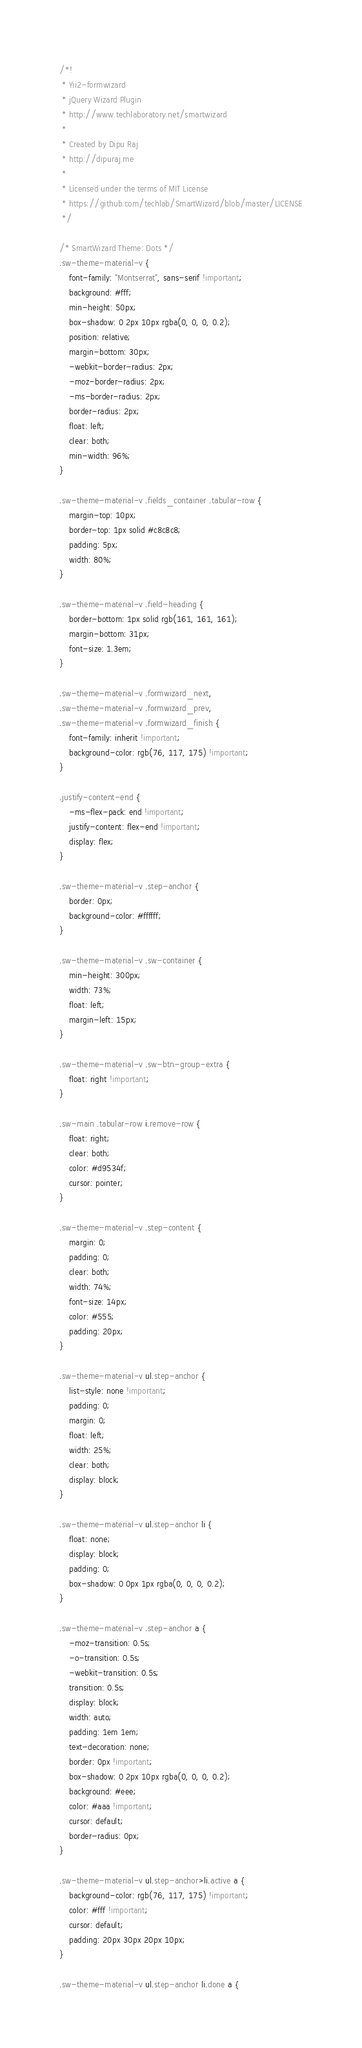Convert code to text. <code><loc_0><loc_0><loc_500><loc_500><_CSS_>/*!
 * Yii2-formwizard
 * jQuery Wizard Plugin
 * http://www.techlaboratory.net/smartwizard
 *
 * Created by Dipu Raj
 * http://dipuraj.me
 *
 * Licensed under the terms of MIT License
 * https://github.com/techlab/SmartWizard/blob/master/LICENSE
 */

/* SmartWizard Theme: Dots */
.sw-theme-material-v {
    font-family: "Montserrat", sans-serif !important;
    background: #fff;
    min-height: 50px;
    box-shadow: 0 2px 10px rgba(0, 0, 0, 0.2);
    position: relative;
    margin-bottom: 30px;
    -webkit-border-radius: 2px;
    -moz-border-radius: 2px;
    -ms-border-radius: 2px;
    border-radius: 2px;
    float: left;
    clear: both;
    min-width: 96%;
}

.sw-theme-material-v .fields_container .tabular-row {
    margin-top: 10px;
    border-top: 1px solid #c8c8c8;
    padding: 5px;
    width: 80%;
}

.sw-theme-material-v .field-heading {
    border-bottom: 1px solid rgb(161, 161, 161);
    margin-bottom: 31px;
    font-size: 1.3em;
}

.sw-theme-material-v .formwizard_next,
.sw-theme-material-v .formwizard_prev,
.sw-theme-material-v .formwizard_finish {
    font-family: inherit !important;
    background-color: rgb(76, 117, 175) !important;
}

.justify-content-end {
    -ms-flex-pack: end !important;
    justify-content: flex-end !important;
    display: flex;
}

.sw-theme-material-v .step-anchor {
    border: 0px;
    background-color: #ffffff;
}

.sw-theme-material-v .sw-container {
    min-height: 300px;
    width: 73%;
    float: left;
    margin-left: 15px;
}

.sw-theme-material-v .sw-btn-group-extra {
    float: right !important;
}

.sw-main .tabular-row i.remove-row {
    float: right;
    clear: both;
    color: #d9534f;
    cursor: pointer;
}

.sw-theme-material-v .step-content {
    margin: 0;
    padding: 0;
    clear: both;
    width: 74%;
    font-size: 14px;
    color: #555;
    padding: 20px;
}

.sw-theme-material-v ul.step-anchor {
    list-style: none !important;
    padding: 0;
    margin: 0;
    float: left;
    width: 25%;
    clear: both;
    display: block;
}

.sw-theme-material-v ul.step-anchor li {
    float: none;
    display: block;
    padding: 0;
    box-shadow: 0 0px 1px rgba(0, 0, 0, 0.2);
}

.sw-theme-material-v .step-anchor a {
    -moz-transition: 0.5s;
    -o-transition: 0.5s;
    -webkit-transition: 0.5s;
    transition: 0.5s;
    display: block;
    width: auto;
    padding: 1em 1em;
    text-decoration: none;
    border: 0px !important;
    box-shadow: 0 2px 10px rgba(0, 0, 0, 0.2);
    background: #eee;
    color: #aaa !important;
    cursor: default;
    border-radius: 0px;
}

.sw-theme-material-v ul.step-anchor>li.active a {
    background-color: rgb(76, 117, 175) !important;
    color: #fff !important;
    cursor: default;
    padding: 20px 30px 20px 10px;
}

.sw-theme-material-v ul.step-anchor li.done a {</code> 